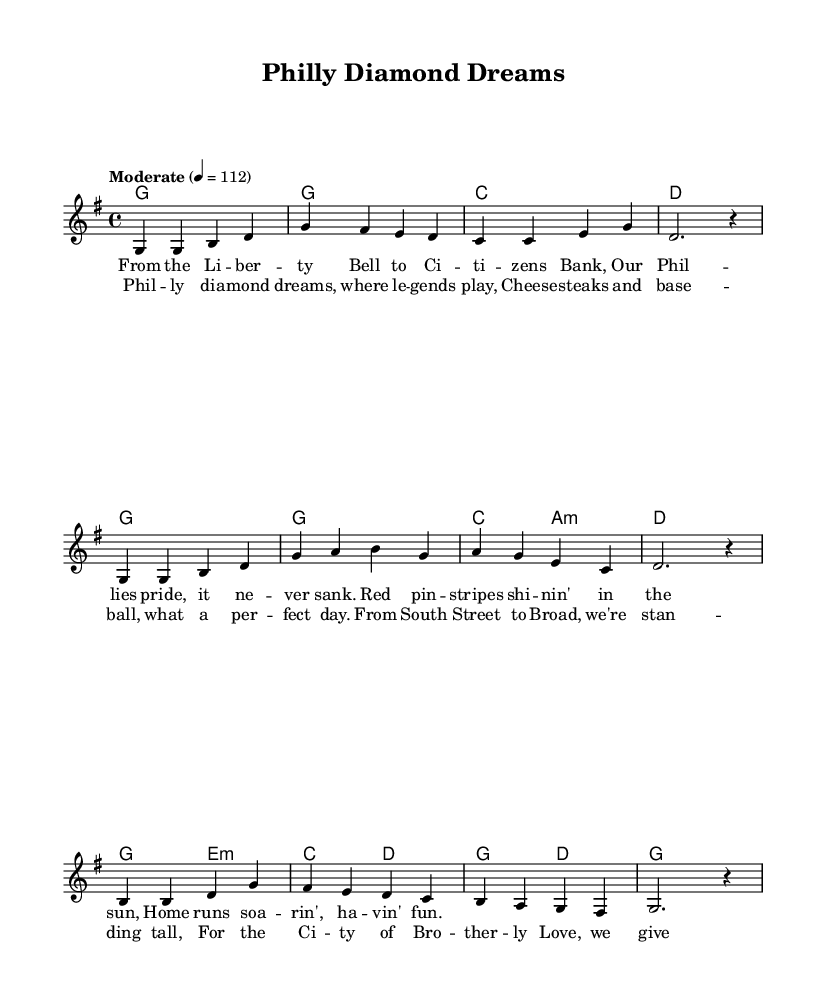What is the key signature of this music? The key signature shown at the beginning of the music indicates that it is in G major, which has one sharp (F#).
Answer: G major What is the time signature of this music? The time signature displayed is 4/4, meaning there are four beats in each measure and the quarter note gets the beat.
Answer: 4/4 What is the tempo marking for this piece? The tempo marking indicates a moderate speed of quarter note equals 112 beats per minute.
Answer: Moderate How many measures are in the chorus section? By counting the measures in the chorus lyrics, there are four distinct lines; each line corresponds to one measure, totaling four measures.
Answer: Four What are the two primary themes of the lyrics? The themes include hometown pride and baseball excitement, focusing on the Philadelphia Phillies and the city’s identity.
Answer: Hometown pride and baseball Which musical element distinguishes this as a Country song? The singable, narrative lyrics that tell a story about local pride and sports are characteristic of Country music.
Answer: Narrative lyrics Which chord is repeated multiple times in the harmony? The G chord is featured prominently and is repeated throughout the harmony section.
Answer: G 